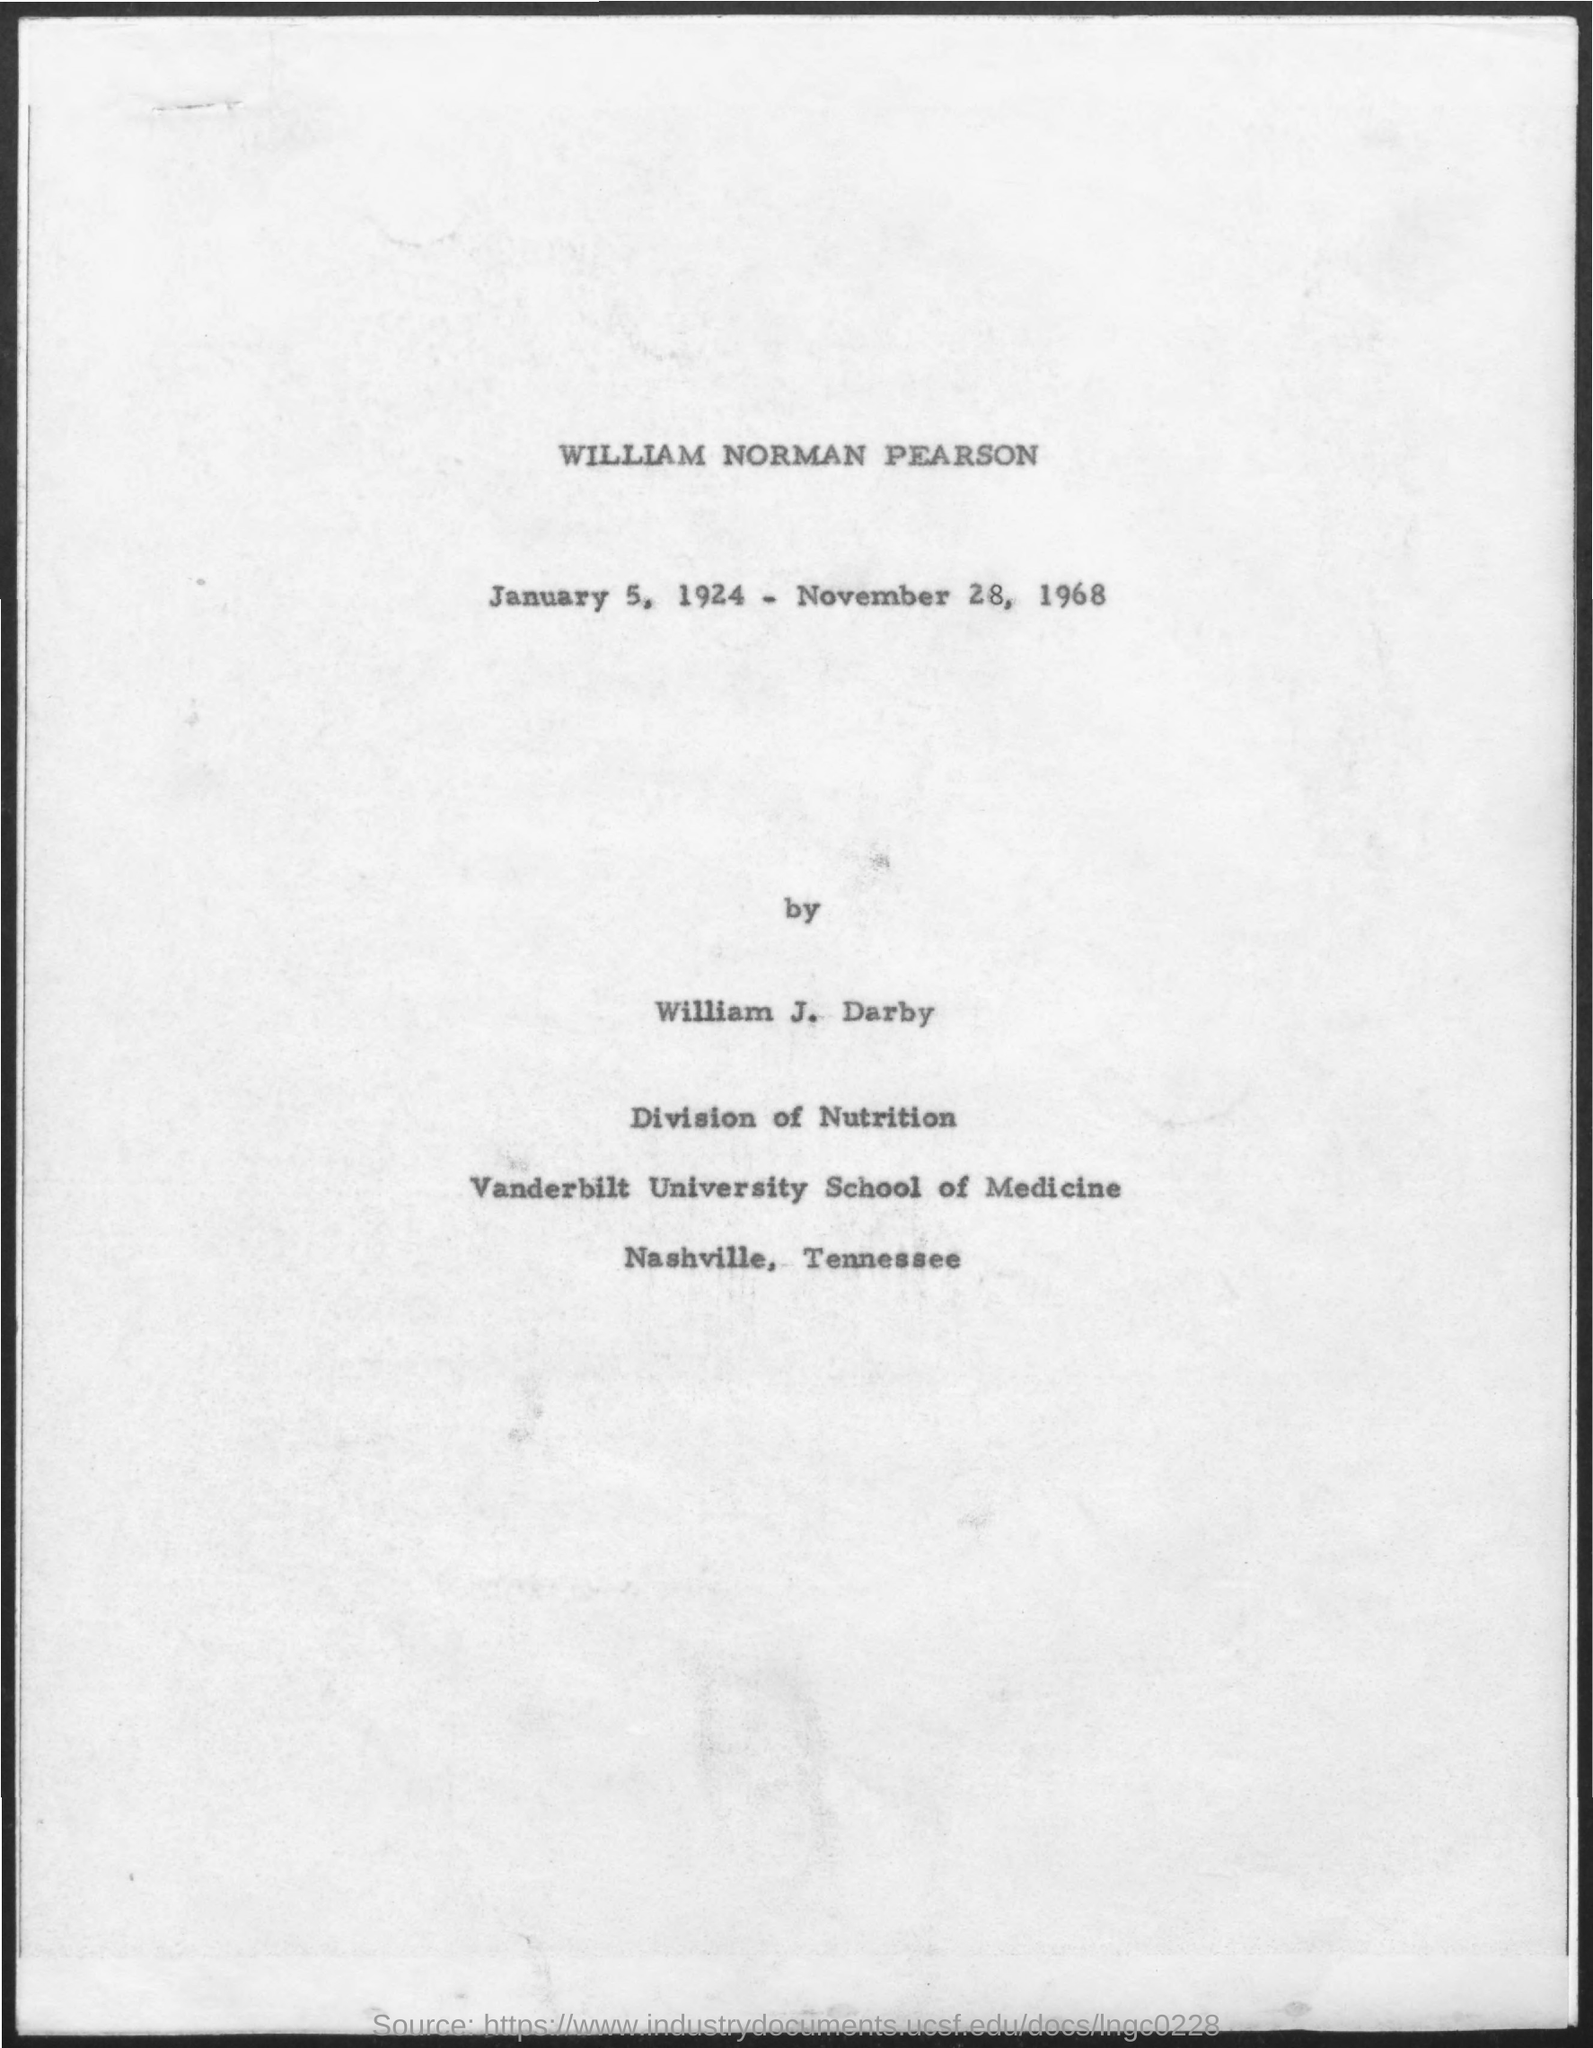Indicate a few pertinent items in this graphic. The first title in the document is "William Norman Pearson. 